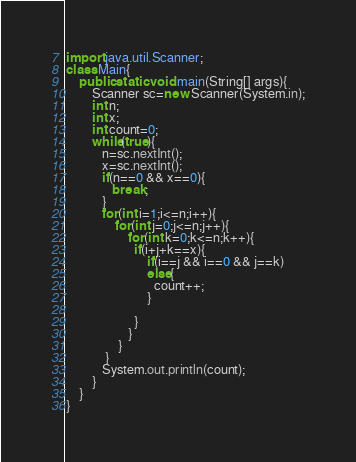<code> <loc_0><loc_0><loc_500><loc_500><_Java_>import java.util.Scanner;
class Main{
    public static void main(String[] args){
        Scanner sc=new Scanner(System.in);
        int n;
        int x;
        int count=0;       
        while(true){
           n=sc.nextInt();
           x=sc.nextInt();
           if(n==0 && x==0){
              break;
           }
           for(int i=1;i<=n;i++){
               for(int j=0;j<=n;j++){
                   for(int k=0;k<=n;k++){
                     if(i+j+k==x){
                         if(i==j && i==0 && j==k)
                         else{
                           count++;  
                         } 
                         
                     }
                   }
                }
            }
           System.out.println(count);
        }
    }
}
</code> 